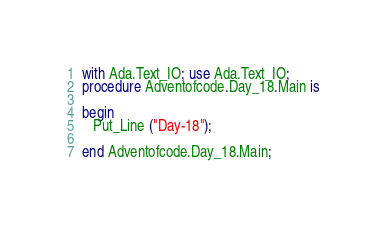Convert code to text. <code><loc_0><loc_0><loc_500><loc_500><_Ada_>with Ada.Text_IO; use Ada.Text_IO;
procedure Adventofcode.Day_18.Main is

begin
   Put_Line ("Day-18");

end Adventofcode.Day_18.Main;
</code> 